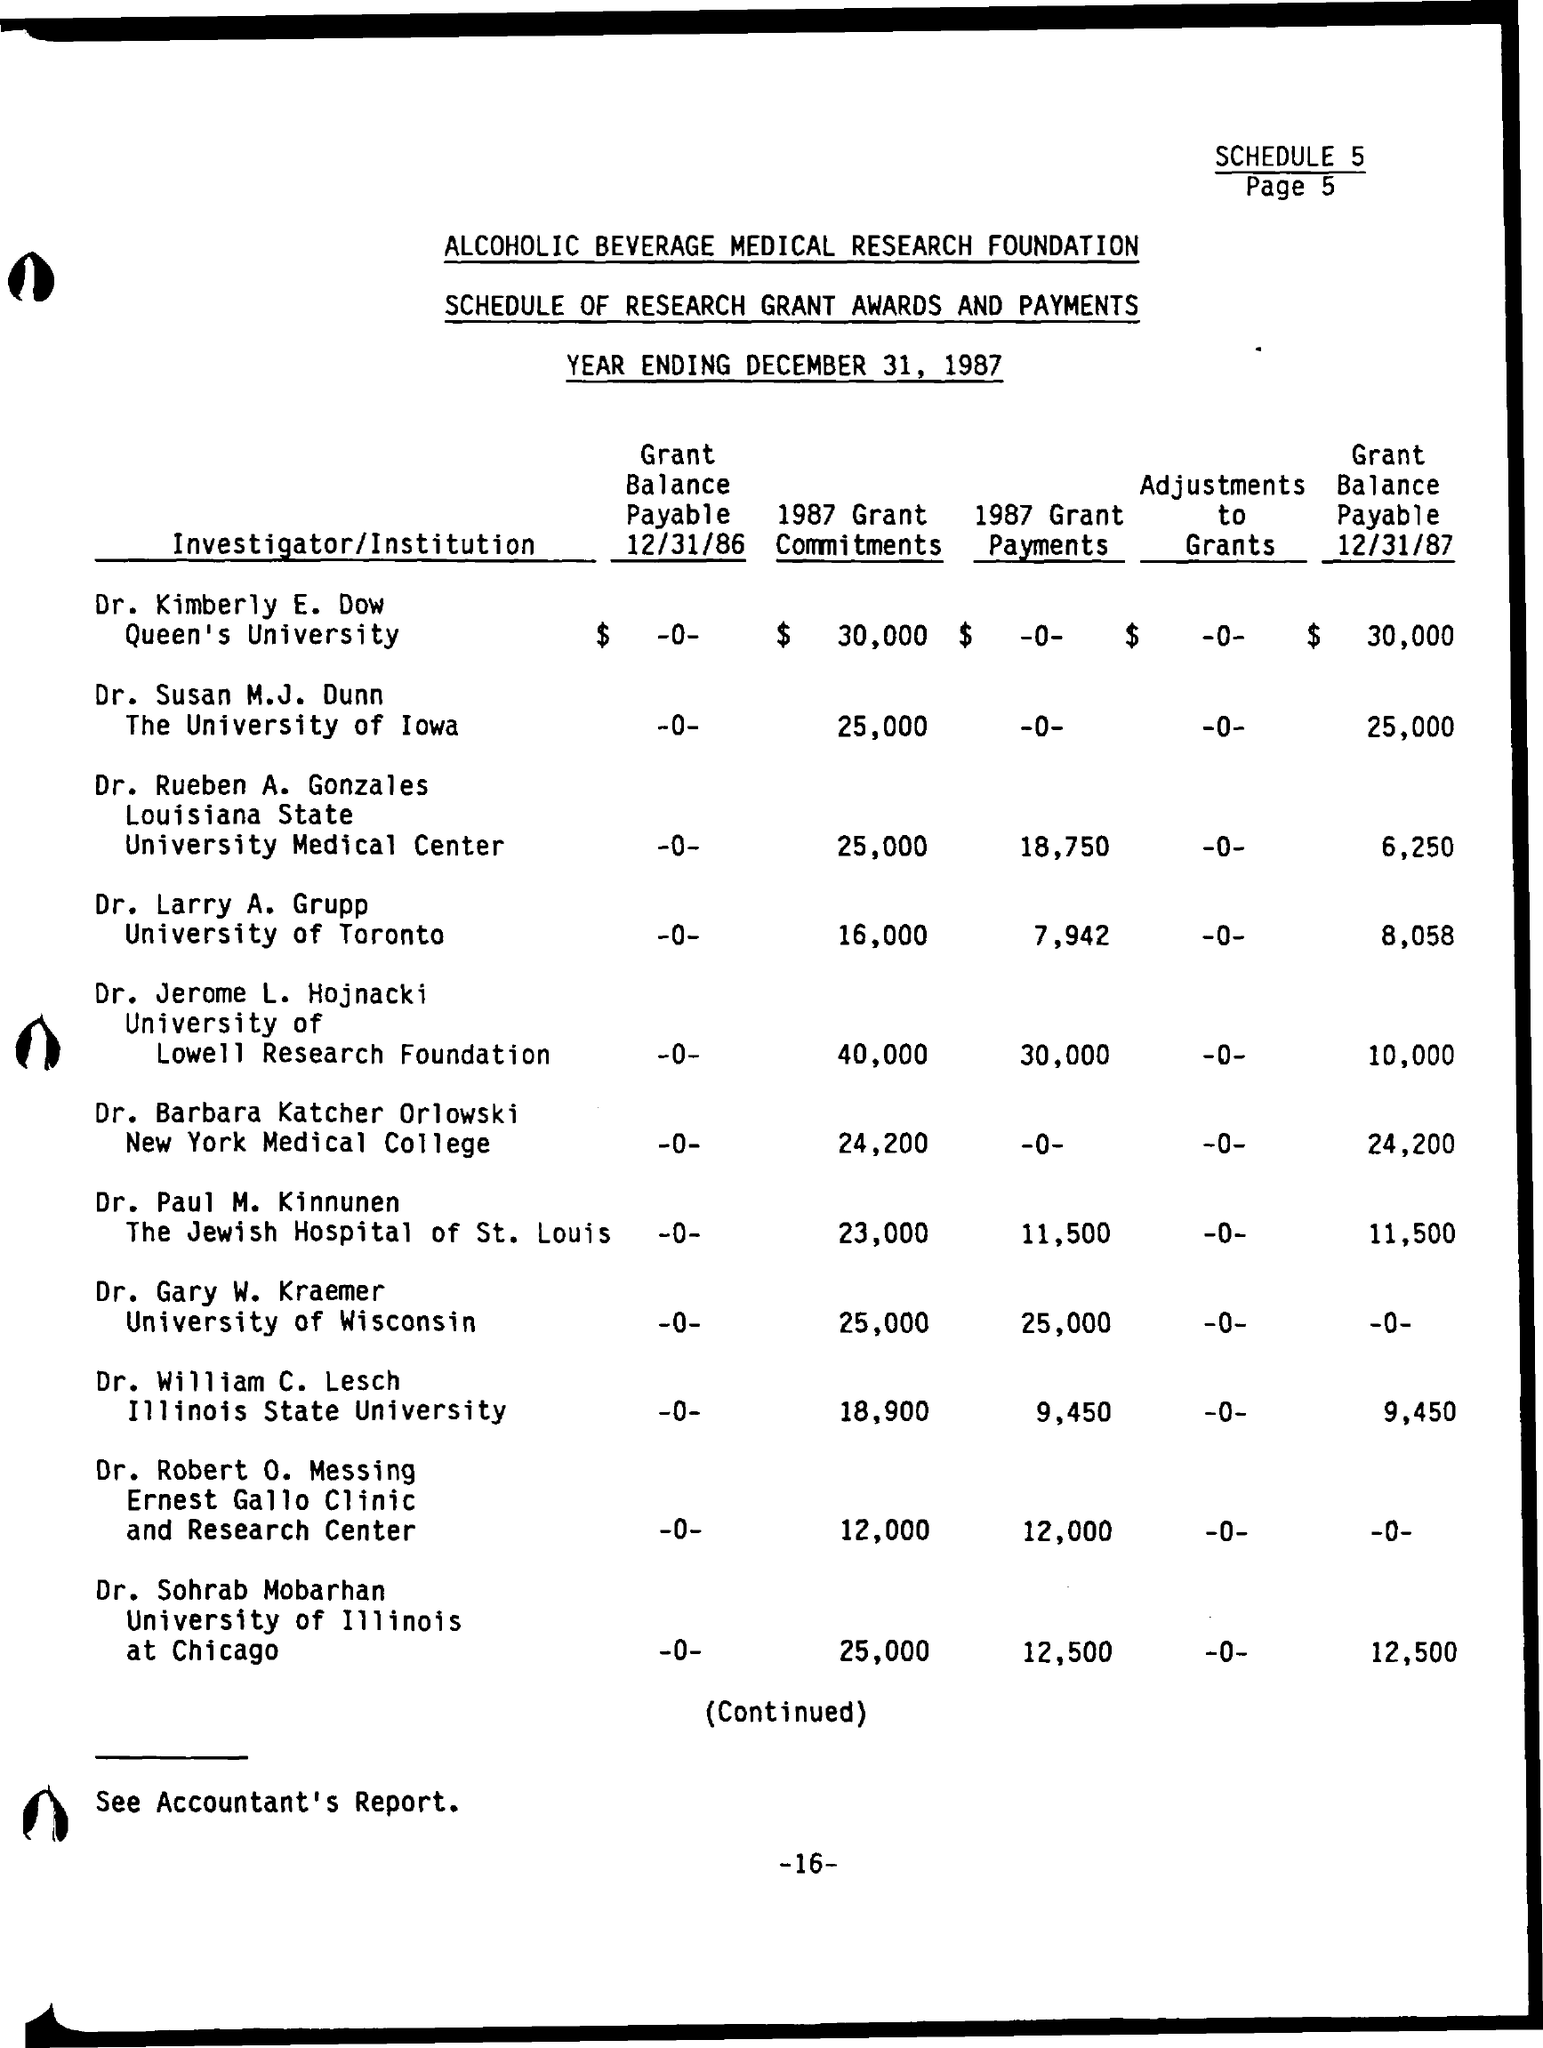Give some essential details in this illustration. The year ending is December 31, 1987. The grant balance payable as of December 31, 1987, was $30,000, paid by Dr. Kimberly E. Dow. 